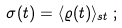Convert formula to latex. <formula><loc_0><loc_0><loc_500><loc_500>\sigma ( t ) = \langle \varrho ( t ) \rangle _ { s t } \, ;</formula> 